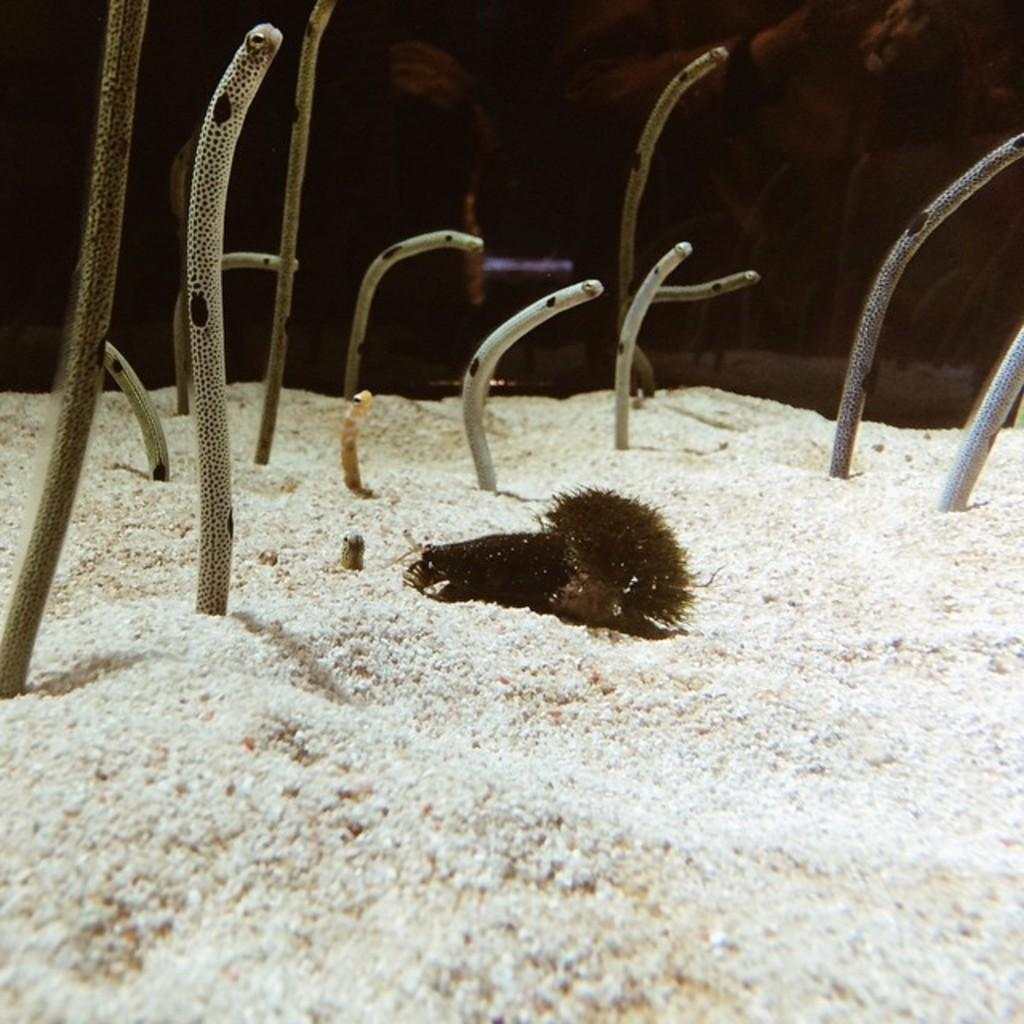What type of animal can be seen in the image? There is an aquatic animal in the image. Where is the aquatic animal located? The aquatic animal is on the sand. What else can be seen in the image besides the aquatic animal? There are plants visible in the image. Can you describe the background of the image? There are people visible behind the aquarium. What time of day is it in the image, considering the morning light? The provided facts do not mention anything about the time of day or the presence of morning light. Therefore, we cannot determine the time of day from the image. 